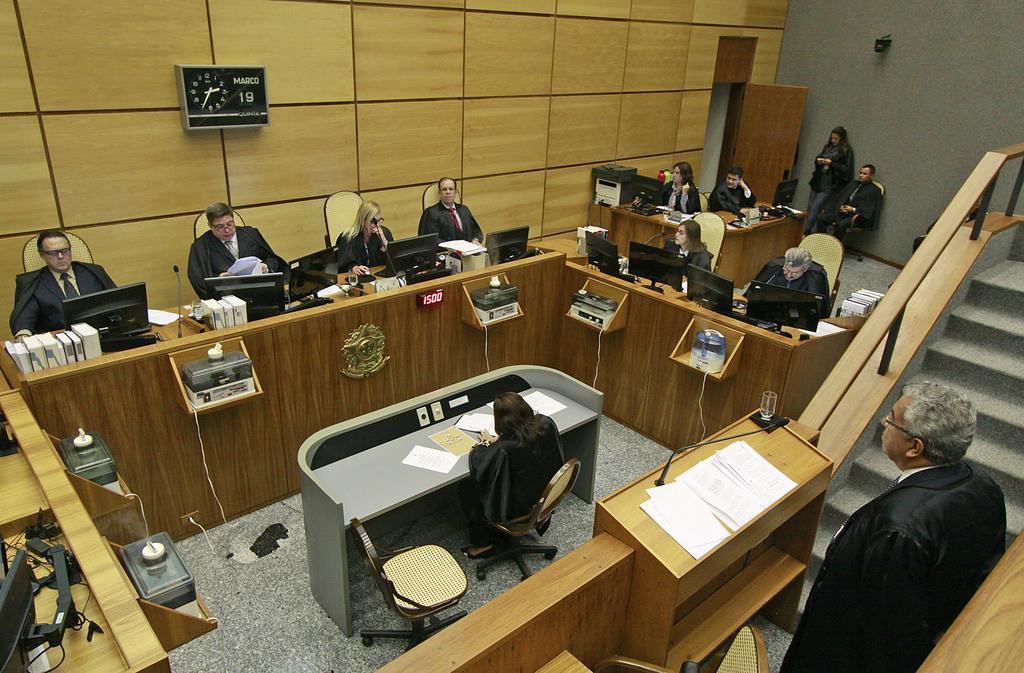Could you give a brief overview of what you see in this image? In this image we can see people sitting on the chairs wearing black coat. We can see monitors ,books, mics and papers on the table. In the background we can see clock on the wooden wall. 